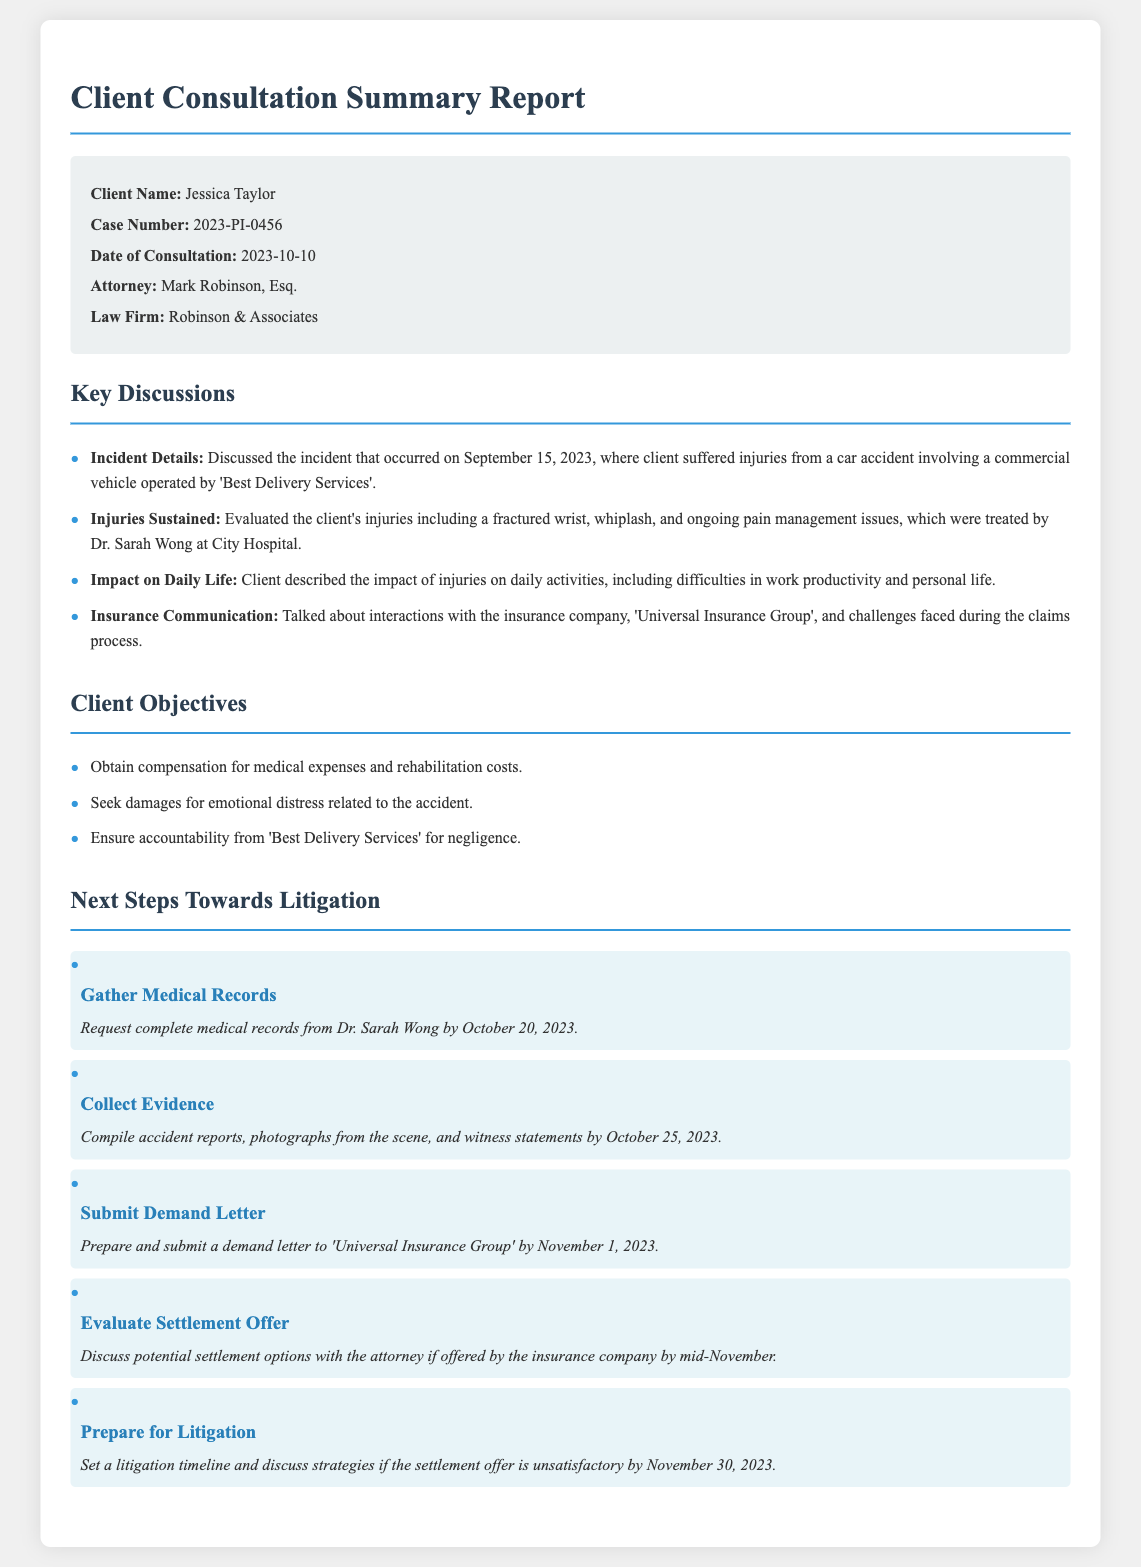What is the client's name? The client's name is explicitly stated in the document.
Answer: Jessica Taylor What is the case number? The case number is specifically mentioned in the document.
Answer: 2023-PI-0456 When did the consultation take place? The date of consultation is highlighted in the document.
Answer: 2023-10-10 Who is the attorney handling the case? The attorney's name is provided in the consultation summary.
Answer: Mark Robinson, Esq What is one of the injuries sustained by the client? The document lists specific injuries sustained by the client.
Answer: Fractured wrist What is the objective related to emotional impact? The document outlines specific client objectives regarding emotional impact.
Answer: Seek damages for emotional distress What are the next steps related to medical records? The document specifies tasks to be done concerning medical records.
Answer: Request complete medical records from Dr. Sarah Wong What is the deadline to submit the demand letter? The document contains a specific deadline for the demand letter submission.
Answer: November 1, 2023 What should be evaluated if a settlement offer is made? The document discusses what should happen if a settlement offer is received.
Answer: Discuss potential settlement options with the attorney 